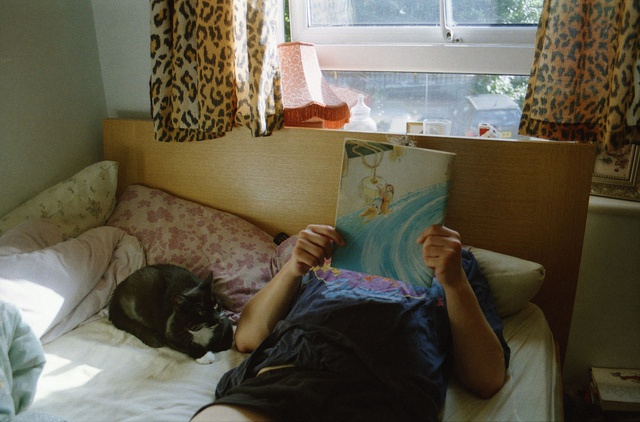Describe the objects in this image and their specific colors. I can see bed in darkgreen, black, gray, olive, and maroon tones, people in darkgreen, black, olive, maroon, and gray tones, book in darkgreen, gray, teal, olive, and black tones, and cat in darkgreen, black, gray, and darkgray tones in this image. 